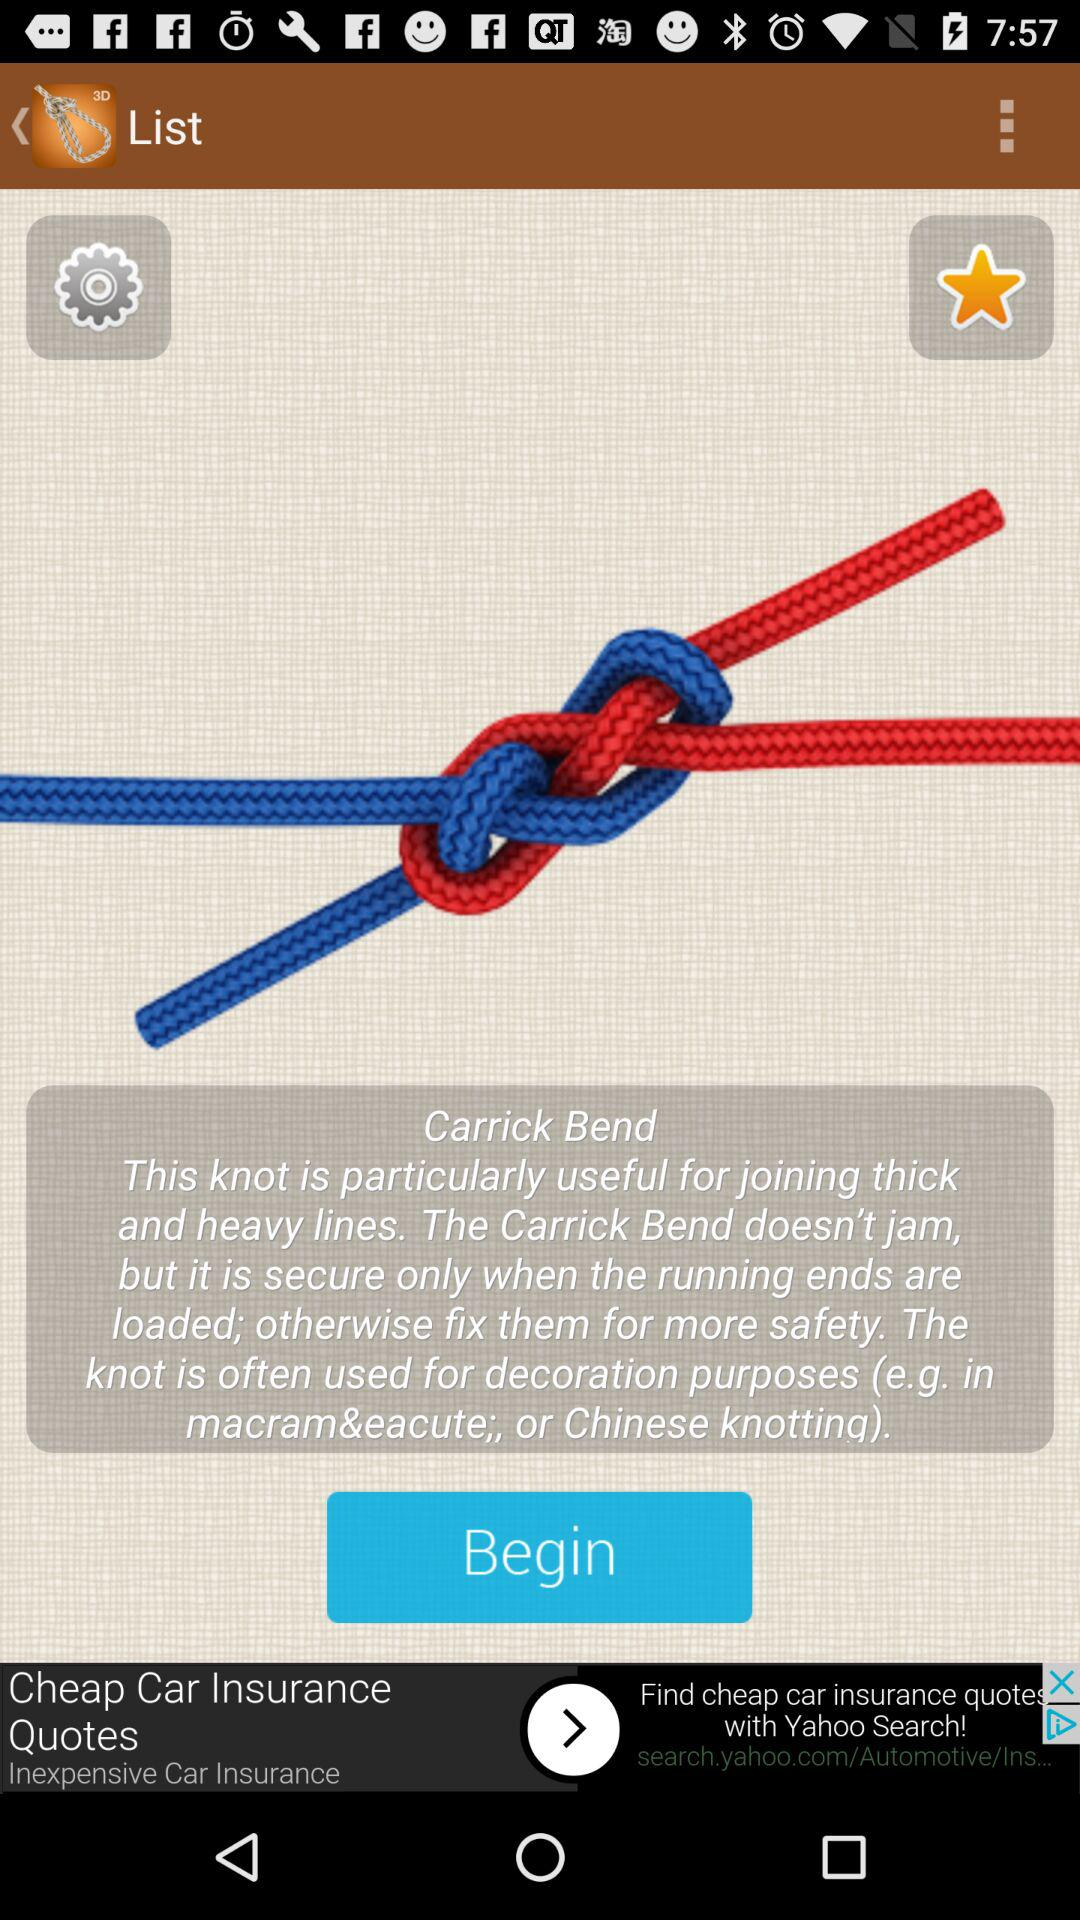What is the knot name? The knot name is "Carrick Bend". 